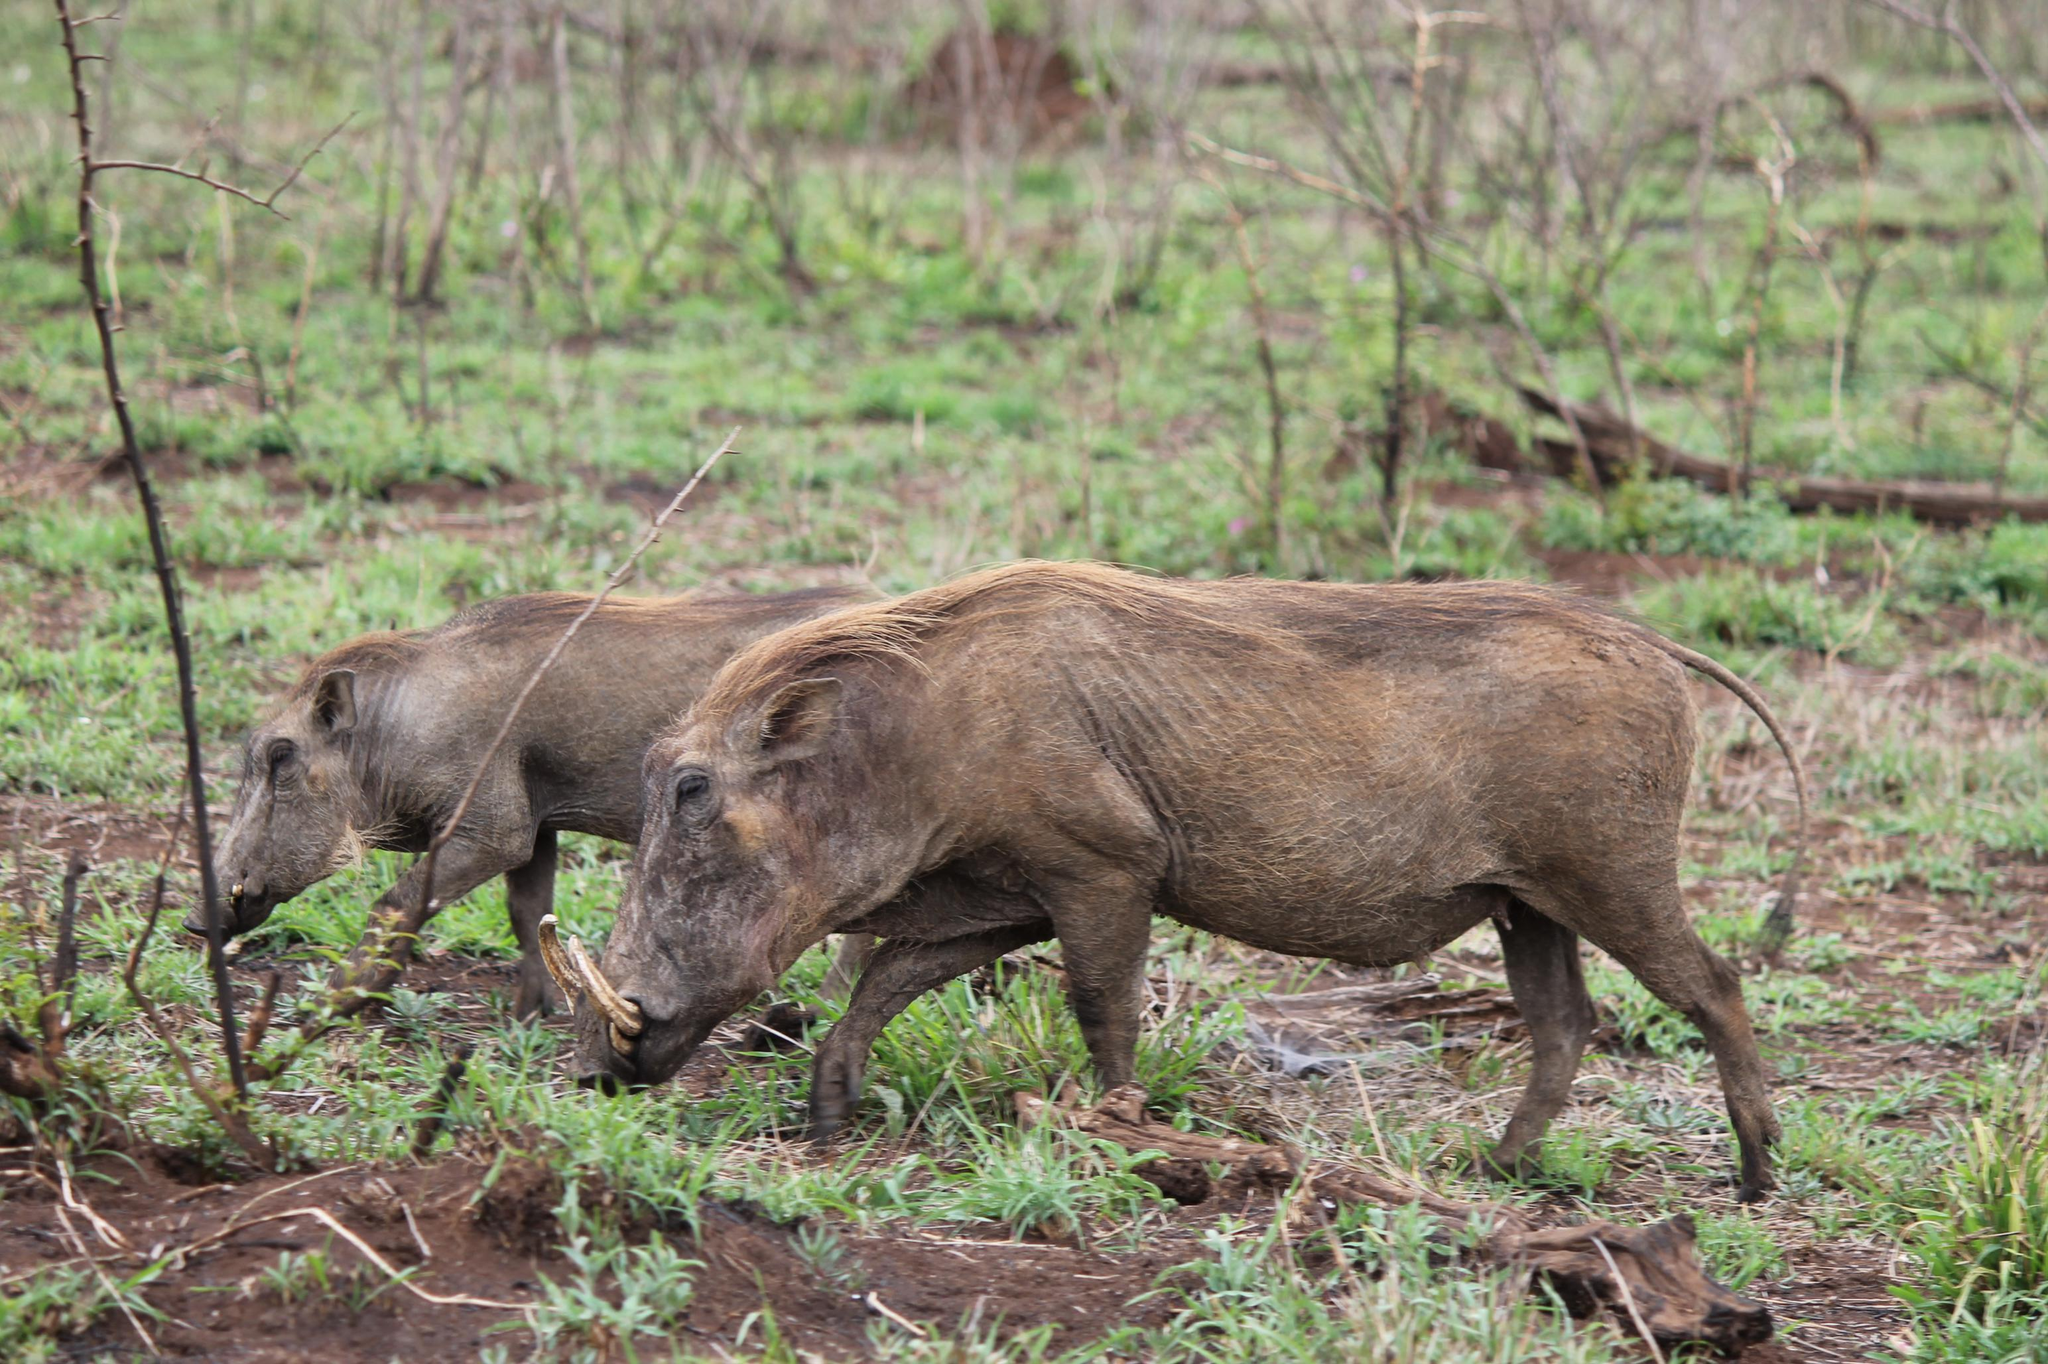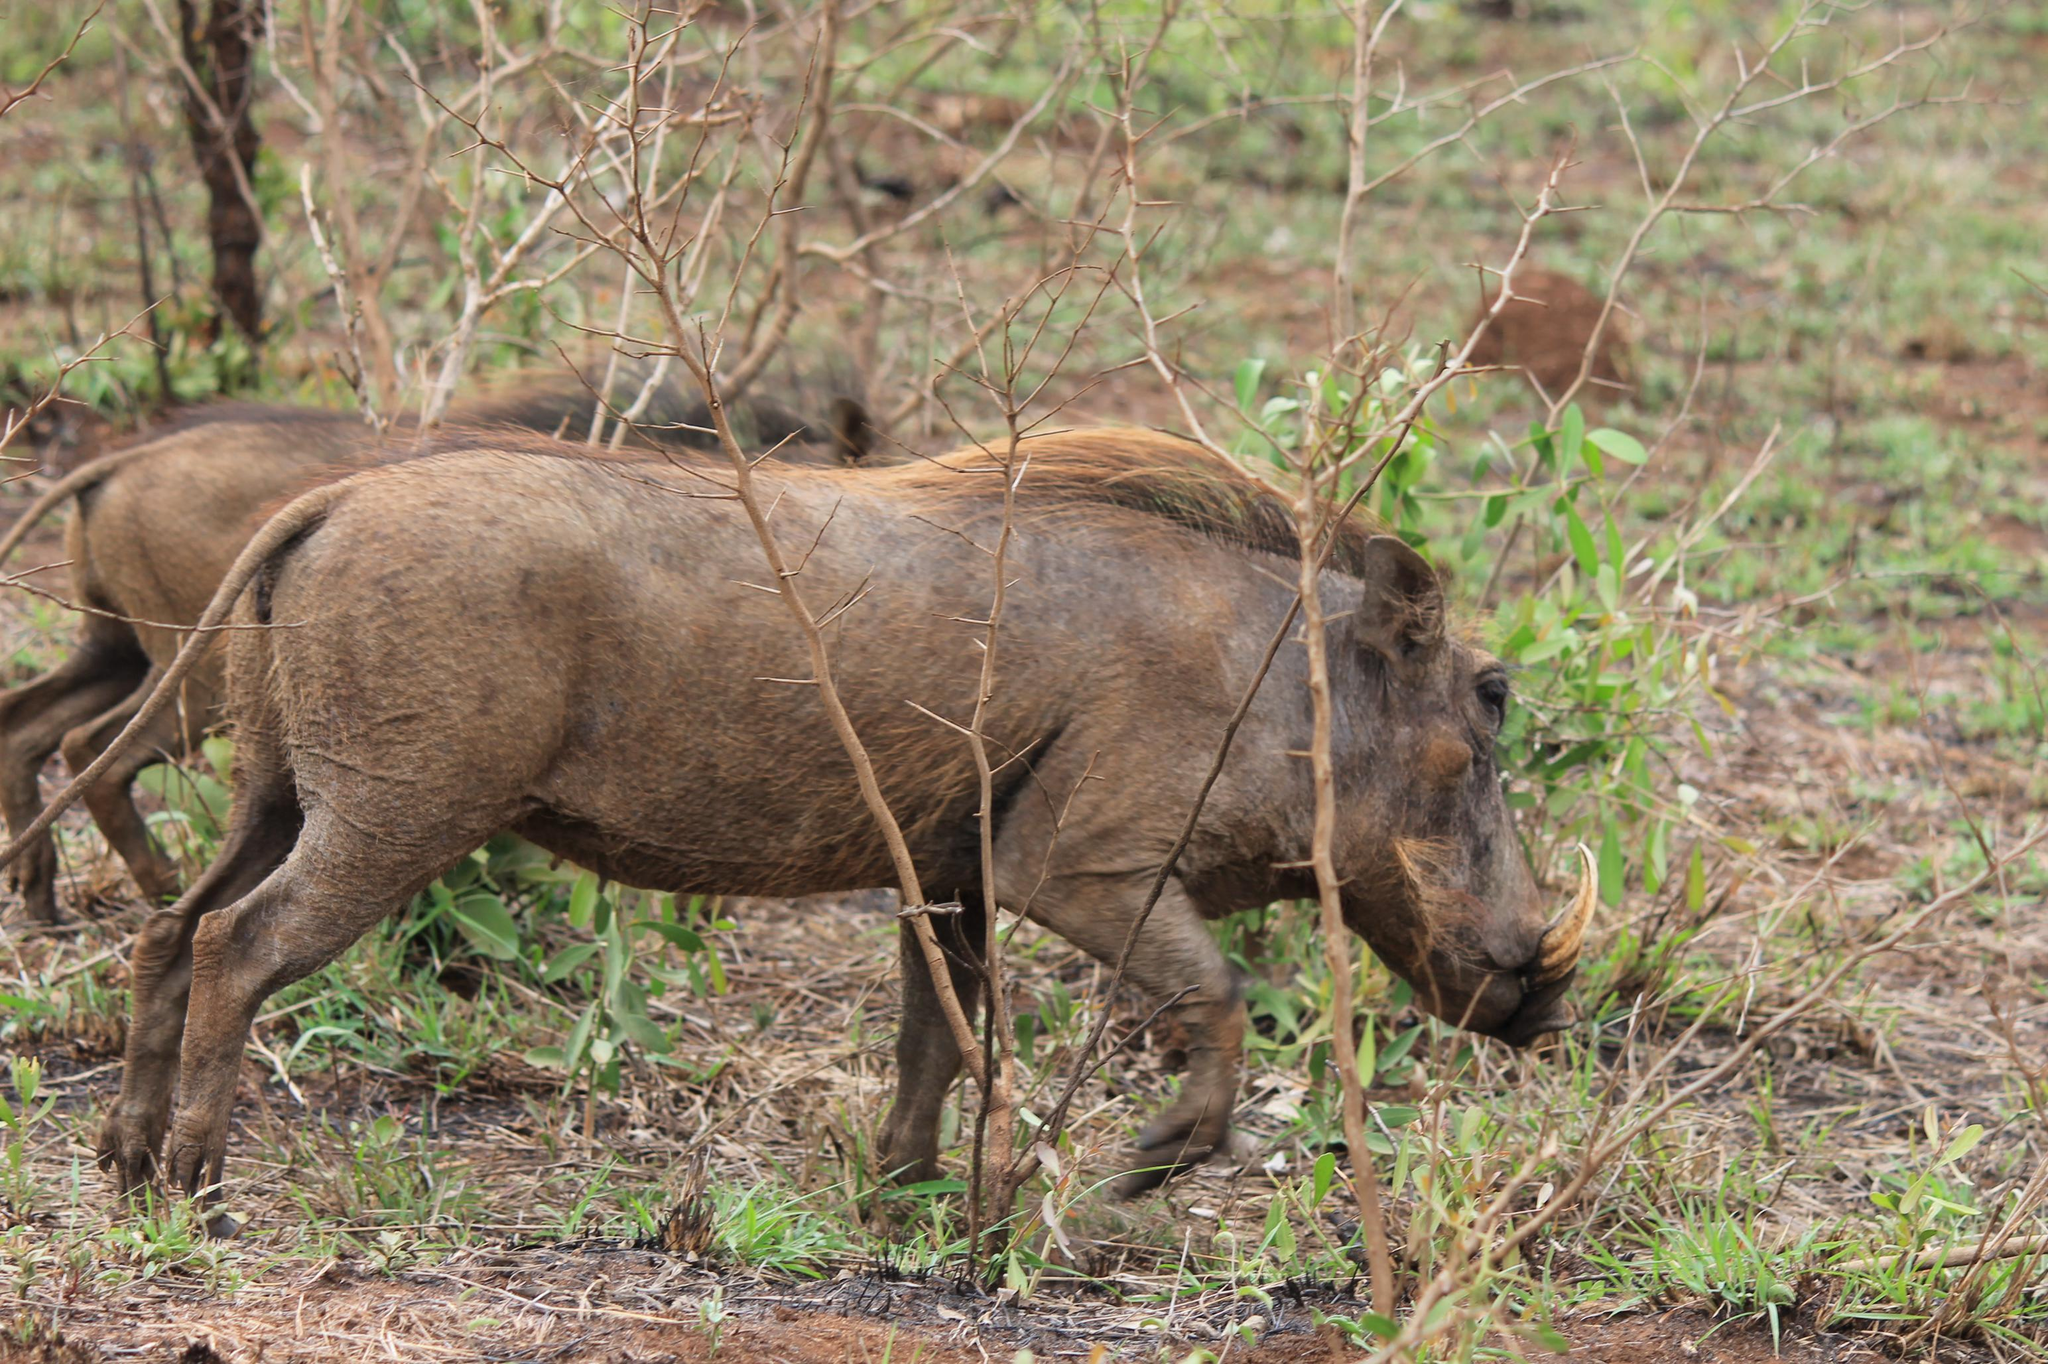The first image is the image on the left, the second image is the image on the right. Considering the images on both sides, is "An image shows exactly one person posed behind a killed warthog." valid? Answer yes or no. No. The first image is the image on the left, the second image is the image on the right. Given the left and right images, does the statement "A hunter is posing near the wild pig in the image on the right." hold true? Answer yes or no. No. 